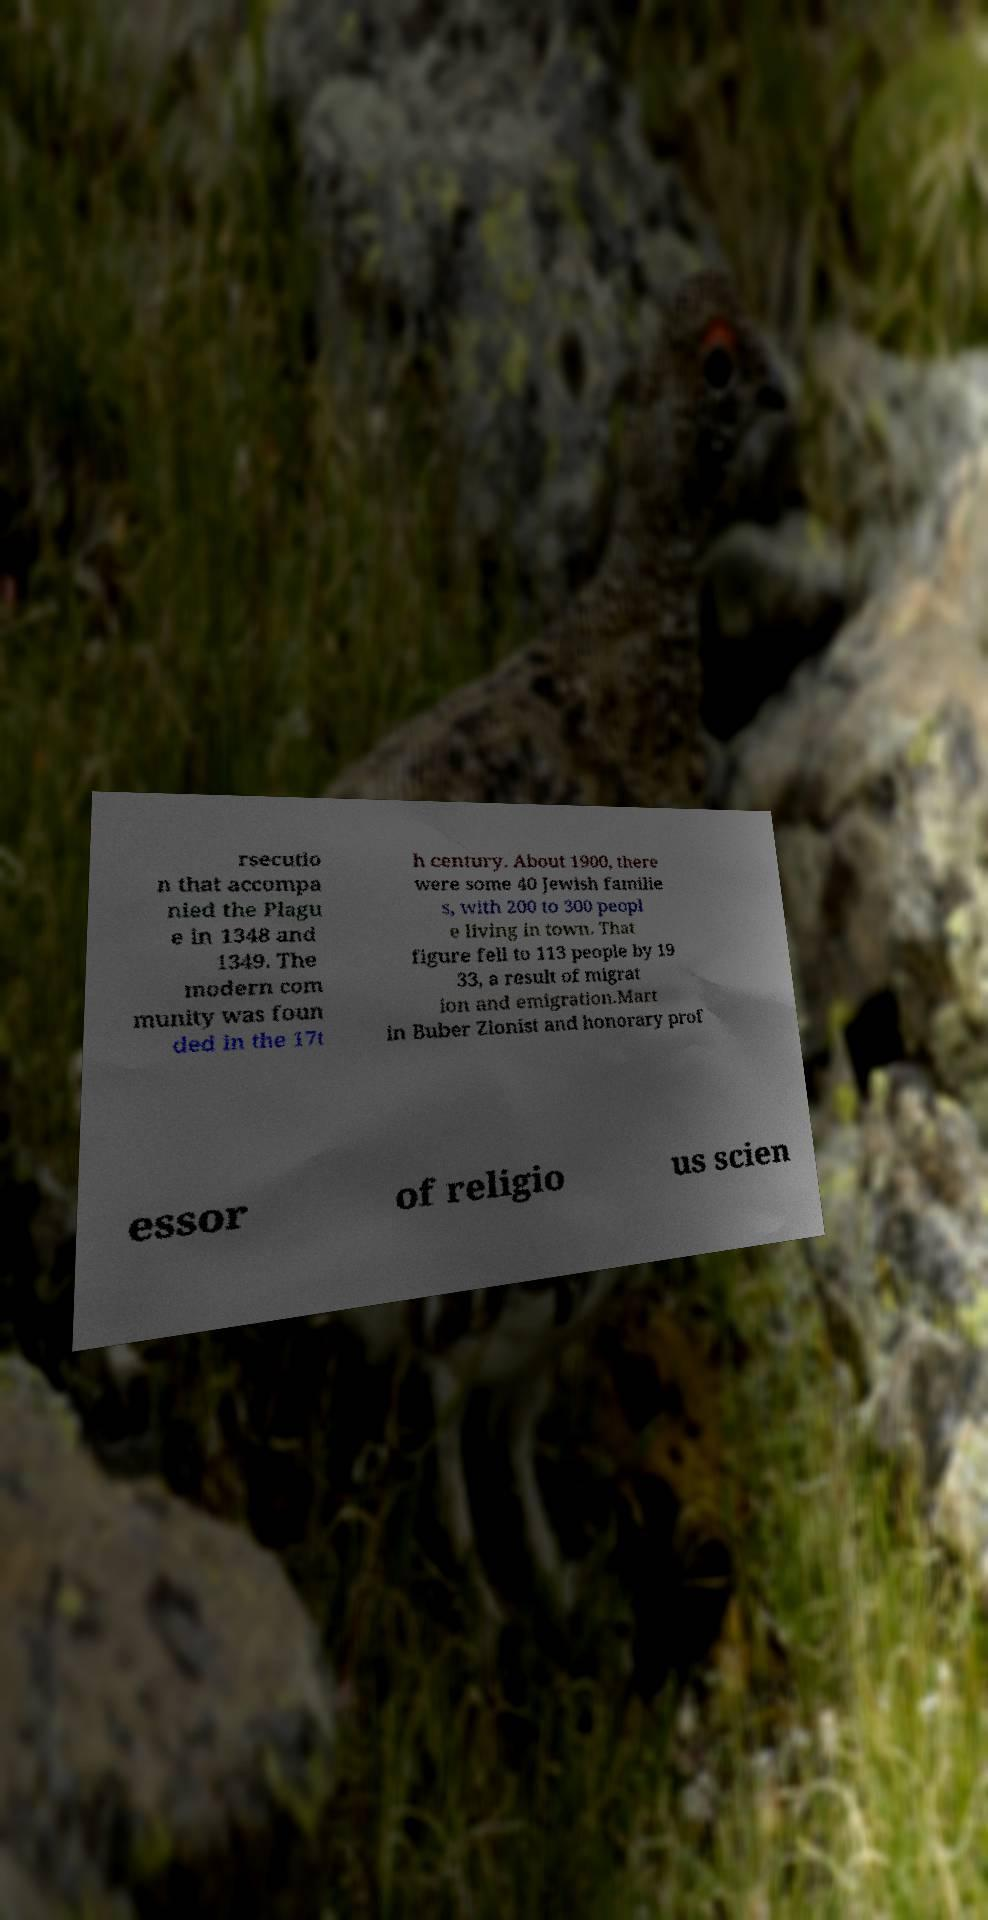Can you accurately transcribe the text from the provided image for me? rsecutio n that accompa nied the Plagu e in 1348 and 1349. The modern com munity was foun ded in the 17t h century. About 1900, there were some 40 Jewish familie s, with 200 to 300 peopl e living in town. That figure fell to 113 people by 19 33, a result of migrat ion and emigration.Mart in Buber Zionist and honorary prof essor of religio us scien 